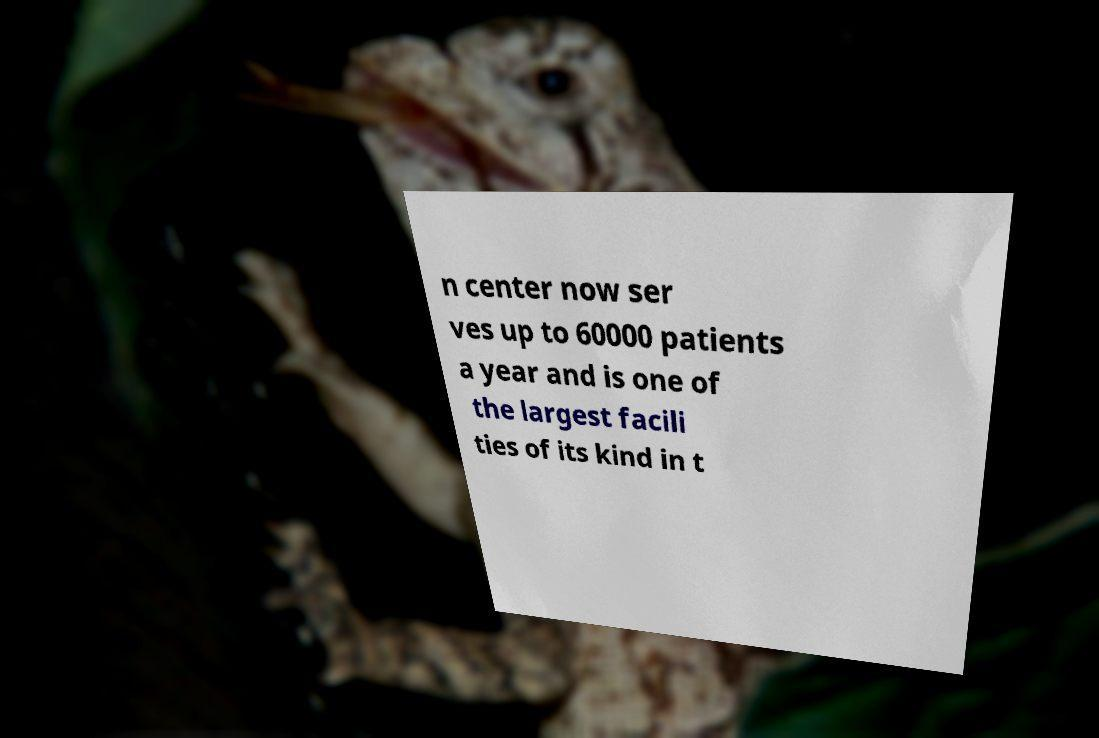There's text embedded in this image that I need extracted. Can you transcribe it verbatim? n center now ser ves up to 60000 patients a year and is one of the largest facili ties of its kind in t 